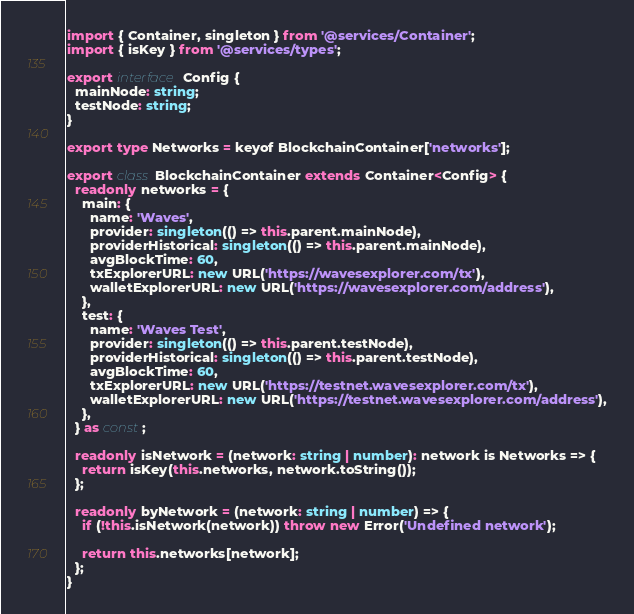Convert code to text. <code><loc_0><loc_0><loc_500><loc_500><_TypeScript_>import { Container, singleton } from '@services/Container';
import { isKey } from '@services/types';

export interface Config {
  mainNode: string;
  testNode: string;
}

export type Networks = keyof BlockchainContainer['networks'];

export class BlockchainContainer extends Container<Config> {
  readonly networks = {
    main: {
      name: 'Waves',
      provider: singleton(() => this.parent.mainNode),
      providerHistorical: singleton(() => this.parent.mainNode),
      avgBlockTime: 60,
      txExplorerURL: new URL('https://wavesexplorer.com/tx'),
      walletExplorerURL: new URL('https://wavesexplorer.com/address'),
    },
    test: {
      name: 'Waves Test',
      provider: singleton(() => this.parent.testNode),
      providerHistorical: singleton(() => this.parent.testNode),
      avgBlockTime: 60,
      txExplorerURL: new URL('https://testnet.wavesexplorer.com/tx'),
      walletExplorerURL: new URL('https://testnet.wavesexplorer.com/address'),
    },
  } as const;

  readonly isNetwork = (network: string | number): network is Networks => {
    return isKey(this.networks, network.toString());
  };

  readonly byNetwork = (network: string | number) => {
    if (!this.isNetwork(network)) throw new Error('Undefined network');

    return this.networks[network];
  };
}
</code> 